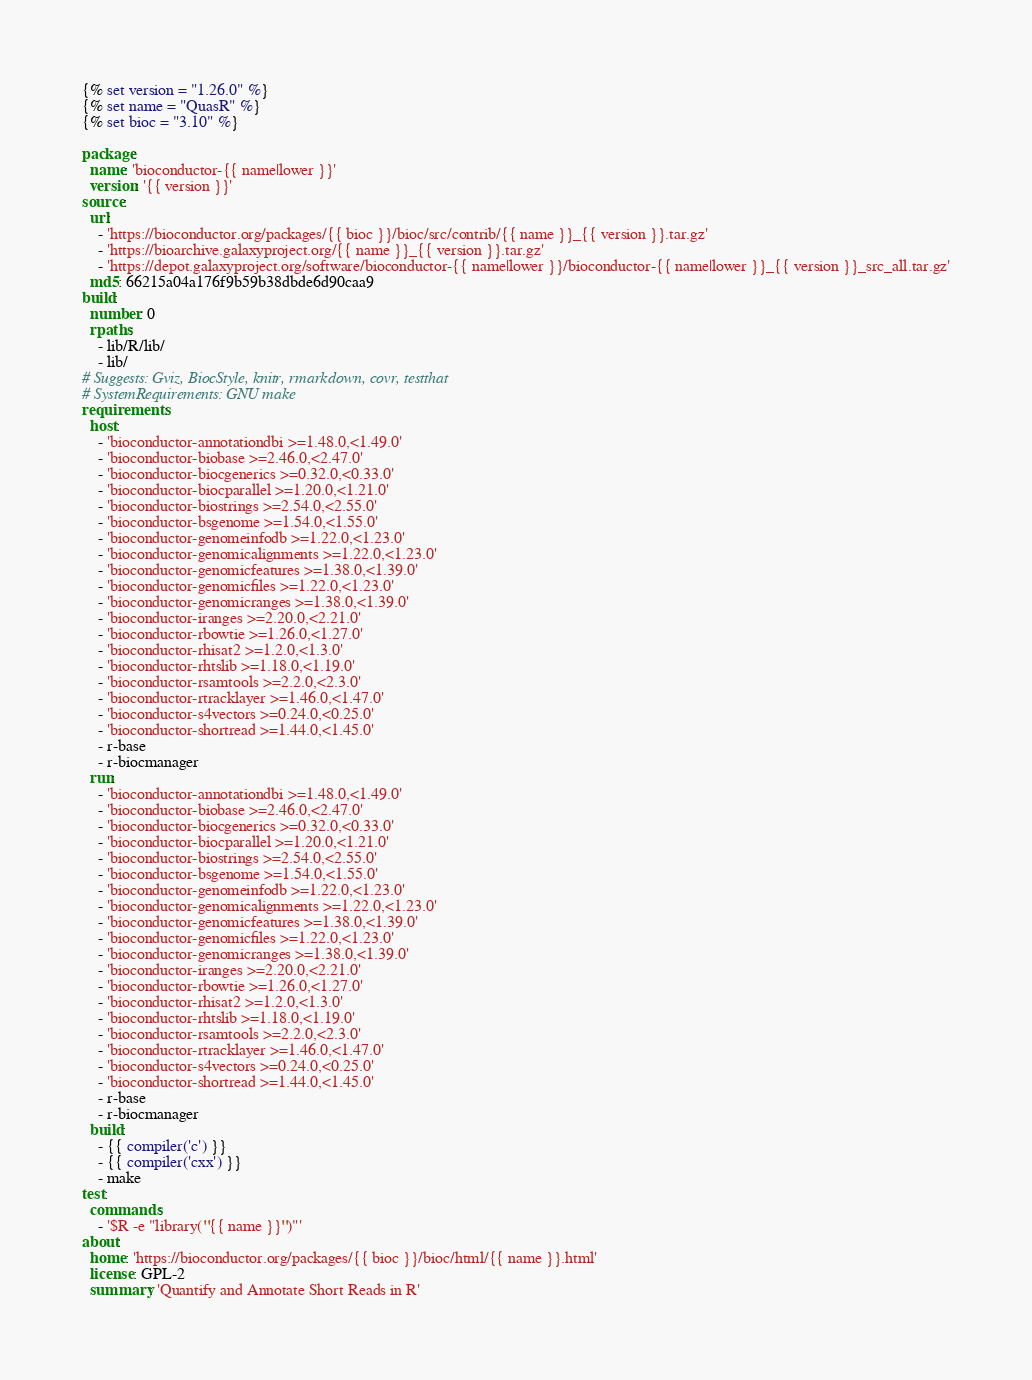<code> <loc_0><loc_0><loc_500><loc_500><_YAML_>{% set version = "1.26.0" %}
{% set name = "QuasR" %}
{% set bioc = "3.10" %}

package:
  name: 'bioconductor-{{ name|lower }}'
  version: '{{ version }}'
source:
  url:
    - 'https://bioconductor.org/packages/{{ bioc }}/bioc/src/contrib/{{ name }}_{{ version }}.tar.gz'
    - 'https://bioarchive.galaxyproject.org/{{ name }}_{{ version }}.tar.gz'
    - 'https://depot.galaxyproject.org/software/bioconductor-{{ name|lower }}/bioconductor-{{ name|lower }}_{{ version }}_src_all.tar.gz'
  md5: 66215a04a176f9b59b38dbde6d90caa9
build:
  number: 0
  rpaths:
    - lib/R/lib/
    - lib/
# Suggests: Gviz, BiocStyle, knitr, rmarkdown, covr, testthat
# SystemRequirements: GNU make
requirements:
  host:
    - 'bioconductor-annotationdbi >=1.48.0,<1.49.0'
    - 'bioconductor-biobase >=2.46.0,<2.47.0'
    - 'bioconductor-biocgenerics >=0.32.0,<0.33.0'
    - 'bioconductor-biocparallel >=1.20.0,<1.21.0'
    - 'bioconductor-biostrings >=2.54.0,<2.55.0'
    - 'bioconductor-bsgenome >=1.54.0,<1.55.0'
    - 'bioconductor-genomeinfodb >=1.22.0,<1.23.0'
    - 'bioconductor-genomicalignments >=1.22.0,<1.23.0'
    - 'bioconductor-genomicfeatures >=1.38.0,<1.39.0'
    - 'bioconductor-genomicfiles >=1.22.0,<1.23.0'
    - 'bioconductor-genomicranges >=1.38.0,<1.39.0'
    - 'bioconductor-iranges >=2.20.0,<2.21.0'
    - 'bioconductor-rbowtie >=1.26.0,<1.27.0'
    - 'bioconductor-rhisat2 >=1.2.0,<1.3.0'
    - 'bioconductor-rhtslib >=1.18.0,<1.19.0'
    - 'bioconductor-rsamtools >=2.2.0,<2.3.0'
    - 'bioconductor-rtracklayer >=1.46.0,<1.47.0'
    - 'bioconductor-s4vectors >=0.24.0,<0.25.0'
    - 'bioconductor-shortread >=1.44.0,<1.45.0'
    - r-base
    - r-biocmanager
  run:
    - 'bioconductor-annotationdbi >=1.48.0,<1.49.0'
    - 'bioconductor-biobase >=2.46.0,<2.47.0'
    - 'bioconductor-biocgenerics >=0.32.0,<0.33.0'
    - 'bioconductor-biocparallel >=1.20.0,<1.21.0'
    - 'bioconductor-biostrings >=2.54.0,<2.55.0'
    - 'bioconductor-bsgenome >=1.54.0,<1.55.0'
    - 'bioconductor-genomeinfodb >=1.22.0,<1.23.0'
    - 'bioconductor-genomicalignments >=1.22.0,<1.23.0'
    - 'bioconductor-genomicfeatures >=1.38.0,<1.39.0'
    - 'bioconductor-genomicfiles >=1.22.0,<1.23.0'
    - 'bioconductor-genomicranges >=1.38.0,<1.39.0'
    - 'bioconductor-iranges >=2.20.0,<2.21.0'
    - 'bioconductor-rbowtie >=1.26.0,<1.27.0'
    - 'bioconductor-rhisat2 >=1.2.0,<1.3.0'
    - 'bioconductor-rhtslib >=1.18.0,<1.19.0'
    - 'bioconductor-rsamtools >=2.2.0,<2.3.0'
    - 'bioconductor-rtracklayer >=1.46.0,<1.47.0'
    - 'bioconductor-s4vectors >=0.24.0,<0.25.0'
    - 'bioconductor-shortread >=1.44.0,<1.45.0'
    - r-base
    - r-biocmanager
  build:
    - {{ compiler('c') }}
    - {{ compiler('cxx') }}
    - make
test:
  commands:
    - '$R -e "library(''{{ name }}'')"'
about:
  home: 'https://bioconductor.org/packages/{{ bioc }}/bioc/html/{{ name }}.html'
  license: GPL-2
  summary: 'Quantify and Annotate Short Reads in R'</code> 